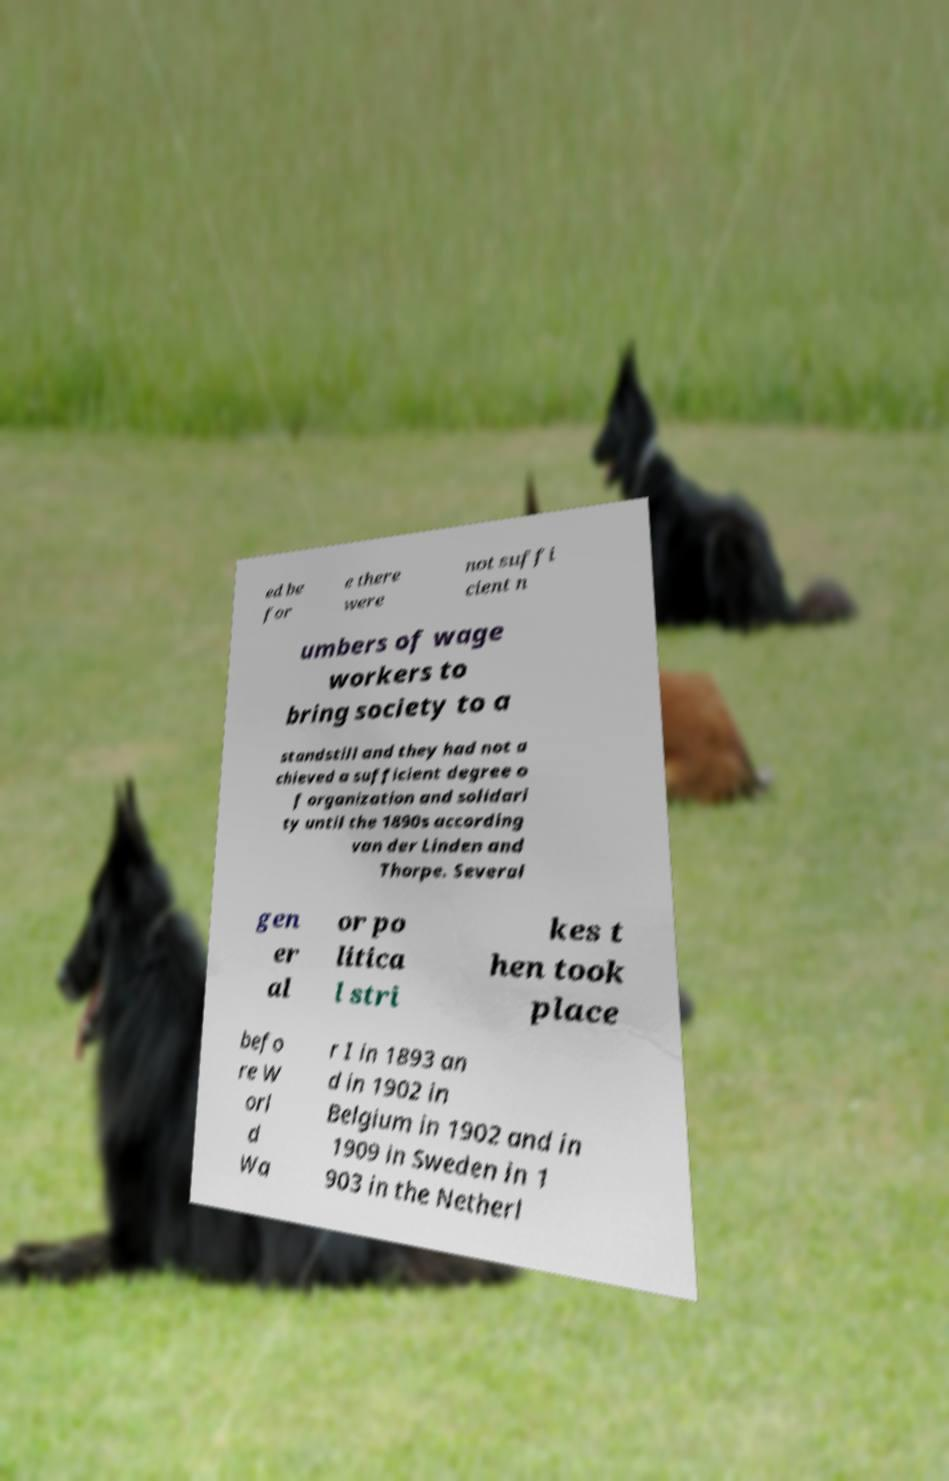I need the written content from this picture converted into text. Can you do that? ed be for e there were not suffi cient n umbers of wage workers to bring society to a standstill and they had not a chieved a sufficient degree o f organization and solidari ty until the 1890s according van der Linden and Thorpe. Several gen er al or po litica l stri kes t hen took place befo re W orl d Wa r I in 1893 an d in 1902 in Belgium in 1902 and in 1909 in Sweden in 1 903 in the Netherl 